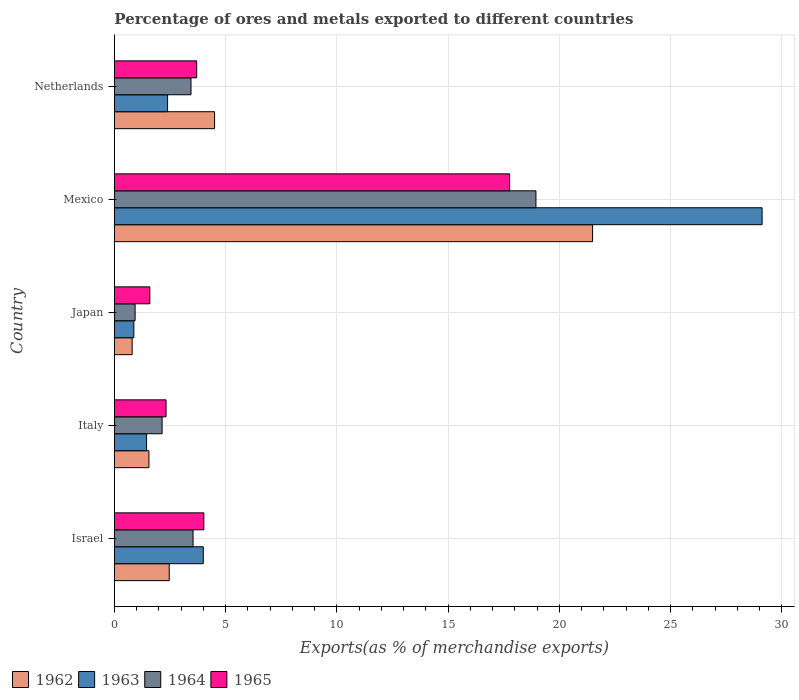How many different coloured bars are there?
Your response must be concise. 4. How many groups of bars are there?
Your answer should be compact. 5. Are the number of bars on each tick of the Y-axis equal?
Offer a terse response. Yes. What is the percentage of exports to different countries in 1964 in Japan?
Your answer should be compact. 0.93. Across all countries, what is the maximum percentage of exports to different countries in 1965?
Keep it short and to the point. 17.76. Across all countries, what is the minimum percentage of exports to different countries in 1965?
Your answer should be very brief. 1.59. In which country was the percentage of exports to different countries in 1964 maximum?
Make the answer very short. Mexico. What is the total percentage of exports to different countries in 1965 in the graph?
Provide a short and direct response. 29.39. What is the difference between the percentage of exports to different countries in 1962 in Israel and that in Italy?
Provide a short and direct response. 0.91. What is the difference between the percentage of exports to different countries in 1963 in Japan and the percentage of exports to different countries in 1965 in Mexico?
Give a very brief answer. -16.89. What is the average percentage of exports to different countries in 1964 per country?
Give a very brief answer. 5.8. What is the difference between the percentage of exports to different countries in 1965 and percentage of exports to different countries in 1963 in Italy?
Give a very brief answer. 0.87. In how many countries, is the percentage of exports to different countries in 1965 greater than 19 %?
Provide a short and direct response. 0. What is the ratio of the percentage of exports to different countries in 1965 in Israel to that in Netherlands?
Your answer should be compact. 1.09. Is the difference between the percentage of exports to different countries in 1965 in Italy and Japan greater than the difference between the percentage of exports to different countries in 1963 in Italy and Japan?
Provide a succinct answer. Yes. What is the difference between the highest and the second highest percentage of exports to different countries in 1964?
Provide a succinct answer. 15.41. What is the difference between the highest and the lowest percentage of exports to different countries in 1964?
Your answer should be very brief. 18.01. In how many countries, is the percentage of exports to different countries in 1965 greater than the average percentage of exports to different countries in 1965 taken over all countries?
Provide a short and direct response. 1. Is it the case that in every country, the sum of the percentage of exports to different countries in 1963 and percentage of exports to different countries in 1962 is greater than the sum of percentage of exports to different countries in 1964 and percentage of exports to different countries in 1965?
Provide a short and direct response. No. What does the 2nd bar from the top in Mexico represents?
Your response must be concise. 1964. What does the 1st bar from the bottom in Israel represents?
Keep it short and to the point. 1962. How many bars are there?
Provide a succinct answer. 20. Are all the bars in the graph horizontal?
Provide a succinct answer. Yes. How many countries are there in the graph?
Offer a very short reply. 5. What is the difference between two consecutive major ticks on the X-axis?
Offer a very short reply. 5. Are the values on the major ticks of X-axis written in scientific E-notation?
Offer a terse response. No. Does the graph contain any zero values?
Your response must be concise. No. Where does the legend appear in the graph?
Offer a terse response. Bottom left. What is the title of the graph?
Your answer should be compact. Percentage of ores and metals exported to different countries. Does "1998" appear as one of the legend labels in the graph?
Offer a very short reply. No. What is the label or title of the X-axis?
Offer a very short reply. Exports(as % of merchandise exports). What is the Exports(as % of merchandise exports) of 1962 in Israel?
Your answer should be very brief. 2.46. What is the Exports(as % of merchandise exports) in 1963 in Israel?
Your answer should be compact. 3.99. What is the Exports(as % of merchandise exports) in 1964 in Israel?
Your answer should be very brief. 3.53. What is the Exports(as % of merchandise exports) of 1965 in Israel?
Offer a terse response. 4.02. What is the Exports(as % of merchandise exports) in 1962 in Italy?
Ensure brevity in your answer.  1.55. What is the Exports(as % of merchandise exports) in 1963 in Italy?
Provide a short and direct response. 1.45. What is the Exports(as % of merchandise exports) of 1964 in Italy?
Keep it short and to the point. 2.14. What is the Exports(as % of merchandise exports) in 1965 in Italy?
Your answer should be very brief. 2.32. What is the Exports(as % of merchandise exports) of 1962 in Japan?
Your answer should be compact. 0.8. What is the Exports(as % of merchandise exports) in 1963 in Japan?
Make the answer very short. 0.87. What is the Exports(as % of merchandise exports) of 1964 in Japan?
Make the answer very short. 0.93. What is the Exports(as % of merchandise exports) in 1965 in Japan?
Your answer should be very brief. 1.59. What is the Exports(as % of merchandise exports) of 1962 in Mexico?
Offer a terse response. 21.49. What is the Exports(as % of merchandise exports) in 1963 in Mexico?
Ensure brevity in your answer.  29.11. What is the Exports(as % of merchandise exports) in 1964 in Mexico?
Provide a short and direct response. 18.94. What is the Exports(as % of merchandise exports) in 1965 in Mexico?
Your answer should be very brief. 17.76. What is the Exports(as % of merchandise exports) of 1962 in Netherlands?
Keep it short and to the point. 4.5. What is the Exports(as % of merchandise exports) in 1963 in Netherlands?
Provide a short and direct response. 2.39. What is the Exports(as % of merchandise exports) in 1964 in Netherlands?
Your answer should be compact. 3.44. What is the Exports(as % of merchandise exports) of 1965 in Netherlands?
Keep it short and to the point. 3.7. Across all countries, what is the maximum Exports(as % of merchandise exports) in 1962?
Make the answer very short. 21.49. Across all countries, what is the maximum Exports(as % of merchandise exports) of 1963?
Ensure brevity in your answer.  29.11. Across all countries, what is the maximum Exports(as % of merchandise exports) in 1964?
Your answer should be very brief. 18.94. Across all countries, what is the maximum Exports(as % of merchandise exports) in 1965?
Provide a short and direct response. 17.76. Across all countries, what is the minimum Exports(as % of merchandise exports) in 1962?
Provide a short and direct response. 0.8. Across all countries, what is the minimum Exports(as % of merchandise exports) of 1963?
Make the answer very short. 0.87. Across all countries, what is the minimum Exports(as % of merchandise exports) of 1964?
Provide a succinct answer. 0.93. Across all countries, what is the minimum Exports(as % of merchandise exports) of 1965?
Give a very brief answer. 1.59. What is the total Exports(as % of merchandise exports) of 1962 in the graph?
Keep it short and to the point. 30.8. What is the total Exports(as % of merchandise exports) of 1963 in the graph?
Make the answer very short. 37.81. What is the total Exports(as % of merchandise exports) of 1964 in the graph?
Your answer should be compact. 28.99. What is the total Exports(as % of merchandise exports) in 1965 in the graph?
Provide a short and direct response. 29.39. What is the difference between the Exports(as % of merchandise exports) of 1963 in Israel and that in Italy?
Provide a short and direct response. 2.55. What is the difference between the Exports(as % of merchandise exports) of 1964 in Israel and that in Italy?
Your answer should be compact. 1.39. What is the difference between the Exports(as % of merchandise exports) in 1965 in Israel and that in Italy?
Offer a terse response. 1.7. What is the difference between the Exports(as % of merchandise exports) in 1962 in Israel and that in Japan?
Keep it short and to the point. 1.67. What is the difference between the Exports(as % of merchandise exports) in 1963 in Israel and that in Japan?
Your answer should be compact. 3.12. What is the difference between the Exports(as % of merchandise exports) in 1964 in Israel and that in Japan?
Your response must be concise. 2.6. What is the difference between the Exports(as % of merchandise exports) in 1965 in Israel and that in Japan?
Provide a short and direct response. 2.43. What is the difference between the Exports(as % of merchandise exports) in 1962 in Israel and that in Mexico?
Your response must be concise. -19.03. What is the difference between the Exports(as % of merchandise exports) in 1963 in Israel and that in Mexico?
Give a very brief answer. -25.12. What is the difference between the Exports(as % of merchandise exports) in 1964 in Israel and that in Mexico?
Offer a terse response. -15.41. What is the difference between the Exports(as % of merchandise exports) in 1965 in Israel and that in Mexico?
Your answer should be very brief. -13.74. What is the difference between the Exports(as % of merchandise exports) of 1962 in Israel and that in Netherlands?
Make the answer very short. -2.04. What is the difference between the Exports(as % of merchandise exports) of 1963 in Israel and that in Netherlands?
Offer a very short reply. 1.6. What is the difference between the Exports(as % of merchandise exports) in 1964 in Israel and that in Netherlands?
Your response must be concise. 0.09. What is the difference between the Exports(as % of merchandise exports) of 1965 in Israel and that in Netherlands?
Provide a succinct answer. 0.32. What is the difference between the Exports(as % of merchandise exports) of 1962 in Italy and that in Japan?
Your response must be concise. 0.75. What is the difference between the Exports(as % of merchandise exports) of 1963 in Italy and that in Japan?
Your answer should be very brief. 0.57. What is the difference between the Exports(as % of merchandise exports) of 1964 in Italy and that in Japan?
Keep it short and to the point. 1.21. What is the difference between the Exports(as % of merchandise exports) in 1965 in Italy and that in Japan?
Make the answer very short. 0.73. What is the difference between the Exports(as % of merchandise exports) of 1962 in Italy and that in Mexico?
Provide a short and direct response. -19.94. What is the difference between the Exports(as % of merchandise exports) in 1963 in Italy and that in Mexico?
Offer a terse response. -27.66. What is the difference between the Exports(as % of merchandise exports) of 1964 in Italy and that in Mexico?
Your answer should be compact. -16.8. What is the difference between the Exports(as % of merchandise exports) in 1965 in Italy and that in Mexico?
Your answer should be compact. -15.44. What is the difference between the Exports(as % of merchandise exports) of 1962 in Italy and that in Netherlands?
Your response must be concise. -2.95. What is the difference between the Exports(as % of merchandise exports) of 1963 in Italy and that in Netherlands?
Offer a very short reply. -0.94. What is the difference between the Exports(as % of merchandise exports) in 1964 in Italy and that in Netherlands?
Your answer should be very brief. -1.3. What is the difference between the Exports(as % of merchandise exports) of 1965 in Italy and that in Netherlands?
Your answer should be very brief. -1.38. What is the difference between the Exports(as % of merchandise exports) of 1962 in Japan and that in Mexico?
Make the answer very short. -20.69. What is the difference between the Exports(as % of merchandise exports) in 1963 in Japan and that in Mexico?
Ensure brevity in your answer.  -28.24. What is the difference between the Exports(as % of merchandise exports) in 1964 in Japan and that in Mexico?
Make the answer very short. -18.01. What is the difference between the Exports(as % of merchandise exports) in 1965 in Japan and that in Mexico?
Ensure brevity in your answer.  -16.17. What is the difference between the Exports(as % of merchandise exports) of 1962 in Japan and that in Netherlands?
Ensure brevity in your answer.  -3.7. What is the difference between the Exports(as % of merchandise exports) of 1963 in Japan and that in Netherlands?
Make the answer very short. -1.52. What is the difference between the Exports(as % of merchandise exports) in 1964 in Japan and that in Netherlands?
Give a very brief answer. -2.51. What is the difference between the Exports(as % of merchandise exports) of 1965 in Japan and that in Netherlands?
Your answer should be very brief. -2.11. What is the difference between the Exports(as % of merchandise exports) in 1962 in Mexico and that in Netherlands?
Your response must be concise. 16.99. What is the difference between the Exports(as % of merchandise exports) of 1963 in Mexico and that in Netherlands?
Give a very brief answer. 26.72. What is the difference between the Exports(as % of merchandise exports) of 1964 in Mexico and that in Netherlands?
Your answer should be compact. 15.5. What is the difference between the Exports(as % of merchandise exports) of 1965 in Mexico and that in Netherlands?
Keep it short and to the point. 14.06. What is the difference between the Exports(as % of merchandise exports) of 1962 in Israel and the Exports(as % of merchandise exports) of 1963 in Italy?
Offer a very short reply. 1.02. What is the difference between the Exports(as % of merchandise exports) in 1962 in Israel and the Exports(as % of merchandise exports) in 1964 in Italy?
Provide a succinct answer. 0.32. What is the difference between the Exports(as % of merchandise exports) in 1962 in Israel and the Exports(as % of merchandise exports) in 1965 in Italy?
Make the answer very short. 0.14. What is the difference between the Exports(as % of merchandise exports) of 1963 in Israel and the Exports(as % of merchandise exports) of 1964 in Italy?
Offer a terse response. 1.85. What is the difference between the Exports(as % of merchandise exports) of 1963 in Israel and the Exports(as % of merchandise exports) of 1965 in Italy?
Provide a short and direct response. 1.67. What is the difference between the Exports(as % of merchandise exports) of 1964 in Israel and the Exports(as % of merchandise exports) of 1965 in Italy?
Offer a terse response. 1.21. What is the difference between the Exports(as % of merchandise exports) in 1962 in Israel and the Exports(as % of merchandise exports) in 1963 in Japan?
Make the answer very short. 1.59. What is the difference between the Exports(as % of merchandise exports) in 1962 in Israel and the Exports(as % of merchandise exports) in 1964 in Japan?
Your response must be concise. 1.53. What is the difference between the Exports(as % of merchandise exports) in 1962 in Israel and the Exports(as % of merchandise exports) in 1965 in Japan?
Offer a very short reply. 0.87. What is the difference between the Exports(as % of merchandise exports) in 1963 in Israel and the Exports(as % of merchandise exports) in 1964 in Japan?
Your answer should be very brief. 3.06. What is the difference between the Exports(as % of merchandise exports) in 1963 in Israel and the Exports(as % of merchandise exports) in 1965 in Japan?
Offer a terse response. 2.4. What is the difference between the Exports(as % of merchandise exports) in 1964 in Israel and the Exports(as % of merchandise exports) in 1965 in Japan?
Make the answer very short. 1.94. What is the difference between the Exports(as % of merchandise exports) in 1962 in Israel and the Exports(as % of merchandise exports) in 1963 in Mexico?
Make the answer very short. -26.64. What is the difference between the Exports(as % of merchandise exports) of 1962 in Israel and the Exports(as % of merchandise exports) of 1964 in Mexico?
Offer a very short reply. -16.48. What is the difference between the Exports(as % of merchandise exports) in 1962 in Israel and the Exports(as % of merchandise exports) in 1965 in Mexico?
Make the answer very short. -15.3. What is the difference between the Exports(as % of merchandise exports) of 1963 in Israel and the Exports(as % of merchandise exports) of 1964 in Mexico?
Offer a very short reply. -14.95. What is the difference between the Exports(as % of merchandise exports) in 1963 in Israel and the Exports(as % of merchandise exports) in 1965 in Mexico?
Your answer should be compact. -13.77. What is the difference between the Exports(as % of merchandise exports) in 1964 in Israel and the Exports(as % of merchandise exports) in 1965 in Mexico?
Provide a short and direct response. -14.23. What is the difference between the Exports(as % of merchandise exports) of 1962 in Israel and the Exports(as % of merchandise exports) of 1963 in Netherlands?
Keep it short and to the point. 0.07. What is the difference between the Exports(as % of merchandise exports) of 1962 in Israel and the Exports(as % of merchandise exports) of 1964 in Netherlands?
Keep it short and to the point. -0.98. What is the difference between the Exports(as % of merchandise exports) in 1962 in Israel and the Exports(as % of merchandise exports) in 1965 in Netherlands?
Ensure brevity in your answer.  -1.23. What is the difference between the Exports(as % of merchandise exports) of 1963 in Israel and the Exports(as % of merchandise exports) of 1964 in Netherlands?
Offer a terse response. 0.55. What is the difference between the Exports(as % of merchandise exports) in 1963 in Israel and the Exports(as % of merchandise exports) in 1965 in Netherlands?
Your response must be concise. 0.3. What is the difference between the Exports(as % of merchandise exports) in 1964 in Israel and the Exports(as % of merchandise exports) in 1965 in Netherlands?
Make the answer very short. -0.16. What is the difference between the Exports(as % of merchandise exports) in 1962 in Italy and the Exports(as % of merchandise exports) in 1963 in Japan?
Your response must be concise. 0.68. What is the difference between the Exports(as % of merchandise exports) in 1962 in Italy and the Exports(as % of merchandise exports) in 1964 in Japan?
Your answer should be compact. 0.62. What is the difference between the Exports(as % of merchandise exports) in 1962 in Italy and the Exports(as % of merchandise exports) in 1965 in Japan?
Your response must be concise. -0.04. What is the difference between the Exports(as % of merchandise exports) in 1963 in Italy and the Exports(as % of merchandise exports) in 1964 in Japan?
Provide a succinct answer. 0.52. What is the difference between the Exports(as % of merchandise exports) of 1963 in Italy and the Exports(as % of merchandise exports) of 1965 in Japan?
Your answer should be compact. -0.15. What is the difference between the Exports(as % of merchandise exports) of 1964 in Italy and the Exports(as % of merchandise exports) of 1965 in Japan?
Your response must be concise. 0.55. What is the difference between the Exports(as % of merchandise exports) in 1962 in Italy and the Exports(as % of merchandise exports) in 1963 in Mexico?
Your answer should be very brief. -27.56. What is the difference between the Exports(as % of merchandise exports) in 1962 in Italy and the Exports(as % of merchandise exports) in 1964 in Mexico?
Your answer should be very brief. -17.39. What is the difference between the Exports(as % of merchandise exports) of 1962 in Italy and the Exports(as % of merchandise exports) of 1965 in Mexico?
Offer a very short reply. -16.21. What is the difference between the Exports(as % of merchandise exports) of 1963 in Italy and the Exports(as % of merchandise exports) of 1964 in Mexico?
Provide a short and direct response. -17.5. What is the difference between the Exports(as % of merchandise exports) of 1963 in Italy and the Exports(as % of merchandise exports) of 1965 in Mexico?
Provide a short and direct response. -16.32. What is the difference between the Exports(as % of merchandise exports) in 1964 in Italy and the Exports(as % of merchandise exports) in 1965 in Mexico?
Keep it short and to the point. -15.62. What is the difference between the Exports(as % of merchandise exports) in 1962 in Italy and the Exports(as % of merchandise exports) in 1963 in Netherlands?
Your answer should be compact. -0.84. What is the difference between the Exports(as % of merchandise exports) in 1962 in Italy and the Exports(as % of merchandise exports) in 1964 in Netherlands?
Keep it short and to the point. -1.89. What is the difference between the Exports(as % of merchandise exports) of 1962 in Italy and the Exports(as % of merchandise exports) of 1965 in Netherlands?
Make the answer very short. -2.15. What is the difference between the Exports(as % of merchandise exports) in 1963 in Italy and the Exports(as % of merchandise exports) in 1964 in Netherlands?
Provide a short and direct response. -2. What is the difference between the Exports(as % of merchandise exports) of 1963 in Italy and the Exports(as % of merchandise exports) of 1965 in Netherlands?
Your answer should be very brief. -2.25. What is the difference between the Exports(as % of merchandise exports) in 1964 in Italy and the Exports(as % of merchandise exports) in 1965 in Netherlands?
Your response must be concise. -1.56. What is the difference between the Exports(as % of merchandise exports) in 1962 in Japan and the Exports(as % of merchandise exports) in 1963 in Mexico?
Make the answer very short. -28.31. What is the difference between the Exports(as % of merchandise exports) in 1962 in Japan and the Exports(as % of merchandise exports) in 1964 in Mexico?
Make the answer very short. -18.15. What is the difference between the Exports(as % of merchandise exports) in 1962 in Japan and the Exports(as % of merchandise exports) in 1965 in Mexico?
Keep it short and to the point. -16.97. What is the difference between the Exports(as % of merchandise exports) of 1963 in Japan and the Exports(as % of merchandise exports) of 1964 in Mexico?
Make the answer very short. -18.07. What is the difference between the Exports(as % of merchandise exports) of 1963 in Japan and the Exports(as % of merchandise exports) of 1965 in Mexico?
Your answer should be compact. -16.89. What is the difference between the Exports(as % of merchandise exports) in 1964 in Japan and the Exports(as % of merchandise exports) in 1965 in Mexico?
Make the answer very short. -16.83. What is the difference between the Exports(as % of merchandise exports) in 1962 in Japan and the Exports(as % of merchandise exports) in 1963 in Netherlands?
Give a very brief answer. -1.59. What is the difference between the Exports(as % of merchandise exports) in 1962 in Japan and the Exports(as % of merchandise exports) in 1964 in Netherlands?
Ensure brevity in your answer.  -2.64. What is the difference between the Exports(as % of merchandise exports) in 1962 in Japan and the Exports(as % of merchandise exports) in 1965 in Netherlands?
Keep it short and to the point. -2.9. What is the difference between the Exports(as % of merchandise exports) of 1963 in Japan and the Exports(as % of merchandise exports) of 1964 in Netherlands?
Offer a very short reply. -2.57. What is the difference between the Exports(as % of merchandise exports) of 1963 in Japan and the Exports(as % of merchandise exports) of 1965 in Netherlands?
Ensure brevity in your answer.  -2.82. What is the difference between the Exports(as % of merchandise exports) of 1964 in Japan and the Exports(as % of merchandise exports) of 1965 in Netherlands?
Your answer should be very brief. -2.77. What is the difference between the Exports(as % of merchandise exports) in 1962 in Mexico and the Exports(as % of merchandise exports) in 1963 in Netherlands?
Provide a succinct answer. 19.1. What is the difference between the Exports(as % of merchandise exports) in 1962 in Mexico and the Exports(as % of merchandise exports) in 1964 in Netherlands?
Provide a succinct answer. 18.05. What is the difference between the Exports(as % of merchandise exports) in 1962 in Mexico and the Exports(as % of merchandise exports) in 1965 in Netherlands?
Provide a succinct answer. 17.79. What is the difference between the Exports(as % of merchandise exports) in 1963 in Mexico and the Exports(as % of merchandise exports) in 1964 in Netherlands?
Offer a very short reply. 25.67. What is the difference between the Exports(as % of merchandise exports) in 1963 in Mexico and the Exports(as % of merchandise exports) in 1965 in Netherlands?
Give a very brief answer. 25.41. What is the difference between the Exports(as % of merchandise exports) of 1964 in Mexico and the Exports(as % of merchandise exports) of 1965 in Netherlands?
Provide a succinct answer. 15.25. What is the average Exports(as % of merchandise exports) of 1962 per country?
Make the answer very short. 6.16. What is the average Exports(as % of merchandise exports) in 1963 per country?
Offer a terse response. 7.56. What is the average Exports(as % of merchandise exports) in 1964 per country?
Make the answer very short. 5.8. What is the average Exports(as % of merchandise exports) of 1965 per country?
Offer a very short reply. 5.88. What is the difference between the Exports(as % of merchandise exports) in 1962 and Exports(as % of merchandise exports) in 1963 in Israel?
Keep it short and to the point. -1.53. What is the difference between the Exports(as % of merchandise exports) in 1962 and Exports(as % of merchandise exports) in 1964 in Israel?
Offer a terse response. -1.07. What is the difference between the Exports(as % of merchandise exports) in 1962 and Exports(as % of merchandise exports) in 1965 in Israel?
Your answer should be compact. -1.56. What is the difference between the Exports(as % of merchandise exports) in 1963 and Exports(as % of merchandise exports) in 1964 in Israel?
Make the answer very short. 0.46. What is the difference between the Exports(as % of merchandise exports) in 1963 and Exports(as % of merchandise exports) in 1965 in Israel?
Your answer should be very brief. -0.03. What is the difference between the Exports(as % of merchandise exports) in 1964 and Exports(as % of merchandise exports) in 1965 in Israel?
Your answer should be compact. -0.49. What is the difference between the Exports(as % of merchandise exports) of 1962 and Exports(as % of merchandise exports) of 1963 in Italy?
Your response must be concise. 0.11. What is the difference between the Exports(as % of merchandise exports) in 1962 and Exports(as % of merchandise exports) in 1964 in Italy?
Offer a very short reply. -0.59. What is the difference between the Exports(as % of merchandise exports) in 1962 and Exports(as % of merchandise exports) in 1965 in Italy?
Offer a terse response. -0.77. What is the difference between the Exports(as % of merchandise exports) of 1963 and Exports(as % of merchandise exports) of 1964 in Italy?
Give a very brief answer. -0.7. What is the difference between the Exports(as % of merchandise exports) of 1963 and Exports(as % of merchandise exports) of 1965 in Italy?
Provide a succinct answer. -0.87. What is the difference between the Exports(as % of merchandise exports) in 1964 and Exports(as % of merchandise exports) in 1965 in Italy?
Your response must be concise. -0.18. What is the difference between the Exports(as % of merchandise exports) in 1962 and Exports(as % of merchandise exports) in 1963 in Japan?
Your response must be concise. -0.08. What is the difference between the Exports(as % of merchandise exports) in 1962 and Exports(as % of merchandise exports) in 1964 in Japan?
Offer a very short reply. -0.13. What is the difference between the Exports(as % of merchandise exports) of 1962 and Exports(as % of merchandise exports) of 1965 in Japan?
Make the answer very short. -0.8. What is the difference between the Exports(as % of merchandise exports) of 1963 and Exports(as % of merchandise exports) of 1964 in Japan?
Give a very brief answer. -0.06. What is the difference between the Exports(as % of merchandise exports) in 1963 and Exports(as % of merchandise exports) in 1965 in Japan?
Provide a succinct answer. -0.72. What is the difference between the Exports(as % of merchandise exports) in 1964 and Exports(as % of merchandise exports) in 1965 in Japan?
Give a very brief answer. -0.66. What is the difference between the Exports(as % of merchandise exports) of 1962 and Exports(as % of merchandise exports) of 1963 in Mexico?
Your response must be concise. -7.62. What is the difference between the Exports(as % of merchandise exports) of 1962 and Exports(as % of merchandise exports) of 1964 in Mexico?
Your answer should be very brief. 2.55. What is the difference between the Exports(as % of merchandise exports) of 1962 and Exports(as % of merchandise exports) of 1965 in Mexico?
Offer a very short reply. 3.73. What is the difference between the Exports(as % of merchandise exports) of 1963 and Exports(as % of merchandise exports) of 1964 in Mexico?
Give a very brief answer. 10.16. What is the difference between the Exports(as % of merchandise exports) in 1963 and Exports(as % of merchandise exports) in 1965 in Mexico?
Keep it short and to the point. 11.35. What is the difference between the Exports(as % of merchandise exports) of 1964 and Exports(as % of merchandise exports) of 1965 in Mexico?
Make the answer very short. 1.18. What is the difference between the Exports(as % of merchandise exports) of 1962 and Exports(as % of merchandise exports) of 1963 in Netherlands?
Ensure brevity in your answer.  2.11. What is the difference between the Exports(as % of merchandise exports) in 1962 and Exports(as % of merchandise exports) in 1964 in Netherlands?
Ensure brevity in your answer.  1.06. What is the difference between the Exports(as % of merchandise exports) of 1962 and Exports(as % of merchandise exports) of 1965 in Netherlands?
Make the answer very short. 0.8. What is the difference between the Exports(as % of merchandise exports) in 1963 and Exports(as % of merchandise exports) in 1964 in Netherlands?
Your answer should be compact. -1.05. What is the difference between the Exports(as % of merchandise exports) in 1963 and Exports(as % of merchandise exports) in 1965 in Netherlands?
Provide a succinct answer. -1.31. What is the difference between the Exports(as % of merchandise exports) of 1964 and Exports(as % of merchandise exports) of 1965 in Netherlands?
Keep it short and to the point. -0.26. What is the ratio of the Exports(as % of merchandise exports) of 1962 in Israel to that in Italy?
Offer a very short reply. 1.59. What is the ratio of the Exports(as % of merchandise exports) of 1963 in Israel to that in Italy?
Your answer should be compact. 2.76. What is the ratio of the Exports(as % of merchandise exports) in 1964 in Israel to that in Italy?
Your response must be concise. 1.65. What is the ratio of the Exports(as % of merchandise exports) in 1965 in Israel to that in Italy?
Give a very brief answer. 1.73. What is the ratio of the Exports(as % of merchandise exports) of 1962 in Israel to that in Japan?
Your answer should be compact. 3.09. What is the ratio of the Exports(as % of merchandise exports) of 1963 in Israel to that in Japan?
Your response must be concise. 4.57. What is the ratio of the Exports(as % of merchandise exports) of 1964 in Israel to that in Japan?
Offer a terse response. 3.8. What is the ratio of the Exports(as % of merchandise exports) of 1965 in Israel to that in Japan?
Keep it short and to the point. 2.52. What is the ratio of the Exports(as % of merchandise exports) of 1962 in Israel to that in Mexico?
Your answer should be compact. 0.11. What is the ratio of the Exports(as % of merchandise exports) in 1963 in Israel to that in Mexico?
Provide a succinct answer. 0.14. What is the ratio of the Exports(as % of merchandise exports) in 1964 in Israel to that in Mexico?
Offer a terse response. 0.19. What is the ratio of the Exports(as % of merchandise exports) in 1965 in Israel to that in Mexico?
Keep it short and to the point. 0.23. What is the ratio of the Exports(as % of merchandise exports) in 1962 in Israel to that in Netherlands?
Your answer should be compact. 0.55. What is the ratio of the Exports(as % of merchandise exports) in 1963 in Israel to that in Netherlands?
Provide a succinct answer. 1.67. What is the ratio of the Exports(as % of merchandise exports) of 1965 in Israel to that in Netherlands?
Ensure brevity in your answer.  1.09. What is the ratio of the Exports(as % of merchandise exports) of 1962 in Italy to that in Japan?
Keep it short and to the point. 1.95. What is the ratio of the Exports(as % of merchandise exports) of 1963 in Italy to that in Japan?
Give a very brief answer. 1.66. What is the ratio of the Exports(as % of merchandise exports) of 1964 in Italy to that in Japan?
Keep it short and to the point. 2.31. What is the ratio of the Exports(as % of merchandise exports) of 1965 in Italy to that in Japan?
Offer a terse response. 1.46. What is the ratio of the Exports(as % of merchandise exports) of 1962 in Italy to that in Mexico?
Your answer should be compact. 0.07. What is the ratio of the Exports(as % of merchandise exports) in 1963 in Italy to that in Mexico?
Offer a terse response. 0.05. What is the ratio of the Exports(as % of merchandise exports) of 1964 in Italy to that in Mexico?
Provide a succinct answer. 0.11. What is the ratio of the Exports(as % of merchandise exports) in 1965 in Italy to that in Mexico?
Provide a succinct answer. 0.13. What is the ratio of the Exports(as % of merchandise exports) of 1962 in Italy to that in Netherlands?
Your response must be concise. 0.34. What is the ratio of the Exports(as % of merchandise exports) of 1963 in Italy to that in Netherlands?
Make the answer very short. 0.6. What is the ratio of the Exports(as % of merchandise exports) in 1964 in Italy to that in Netherlands?
Ensure brevity in your answer.  0.62. What is the ratio of the Exports(as % of merchandise exports) of 1965 in Italy to that in Netherlands?
Keep it short and to the point. 0.63. What is the ratio of the Exports(as % of merchandise exports) of 1962 in Japan to that in Mexico?
Provide a succinct answer. 0.04. What is the ratio of the Exports(as % of merchandise exports) in 1963 in Japan to that in Mexico?
Your answer should be compact. 0.03. What is the ratio of the Exports(as % of merchandise exports) of 1964 in Japan to that in Mexico?
Offer a terse response. 0.05. What is the ratio of the Exports(as % of merchandise exports) of 1965 in Japan to that in Mexico?
Keep it short and to the point. 0.09. What is the ratio of the Exports(as % of merchandise exports) in 1962 in Japan to that in Netherlands?
Keep it short and to the point. 0.18. What is the ratio of the Exports(as % of merchandise exports) in 1963 in Japan to that in Netherlands?
Your answer should be compact. 0.37. What is the ratio of the Exports(as % of merchandise exports) of 1964 in Japan to that in Netherlands?
Provide a short and direct response. 0.27. What is the ratio of the Exports(as % of merchandise exports) in 1965 in Japan to that in Netherlands?
Give a very brief answer. 0.43. What is the ratio of the Exports(as % of merchandise exports) in 1962 in Mexico to that in Netherlands?
Give a very brief answer. 4.77. What is the ratio of the Exports(as % of merchandise exports) in 1963 in Mexico to that in Netherlands?
Offer a terse response. 12.18. What is the ratio of the Exports(as % of merchandise exports) in 1964 in Mexico to that in Netherlands?
Your response must be concise. 5.51. What is the ratio of the Exports(as % of merchandise exports) in 1965 in Mexico to that in Netherlands?
Provide a short and direct response. 4.8. What is the difference between the highest and the second highest Exports(as % of merchandise exports) in 1962?
Provide a succinct answer. 16.99. What is the difference between the highest and the second highest Exports(as % of merchandise exports) in 1963?
Offer a very short reply. 25.12. What is the difference between the highest and the second highest Exports(as % of merchandise exports) of 1964?
Keep it short and to the point. 15.41. What is the difference between the highest and the second highest Exports(as % of merchandise exports) of 1965?
Offer a terse response. 13.74. What is the difference between the highest and the lowest Exports(as % of merchandise exports) of 1962?
Keep it short and to the point. 20.69. What is the difference between the highest and the lowest Exports(as % of merchandise exports) of 1963?
Your answer should be very brief. 28.24. What is the difference between the highest and the lowest Exports(as % of merchandise exports) in 1964?
Give a very brief answer. 18.01. What is the difference between the highest and the lowest Exports(as % of merchandise exports) in 1965?
Keep it short and to the point. 16.17. 